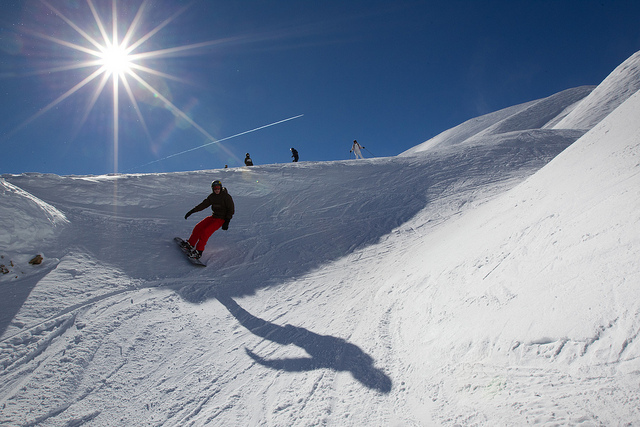What would be the best time of year to go snowboarding in a place like this? The ideal time for snowboarding in locations such as this one would be during the winter months, when snowfall is abundant, usually from late November to early April, depending on the specific region and climate conditions. 